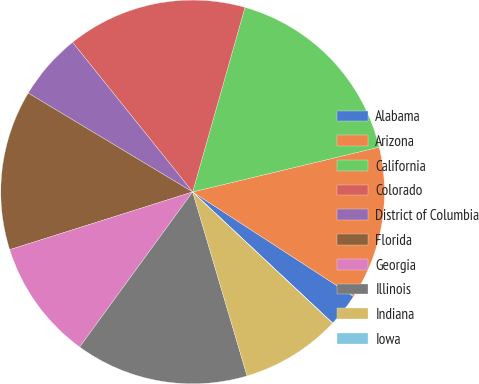Convert chart. <chart><loc_0><loc_0><loc_500><loc_500><pie_chart><fcel>Alabama<fcel>Arizona<fcel>California<fcel>Colorado<fcel>District of Columbia<fcel>Florida<fcel>Georgia<fcel>Illinois<fcel>Indiana<fcel>Iowa<nl><fcel>2.81%<fcel>12.92%<fcel>16.85%<fcel>15.16%<fcel>5.62%<fcel>13.48%<fcel>10.11%<fcel>14.6%<fcel>8.43%<fcel>0.01%<nl></chart> 